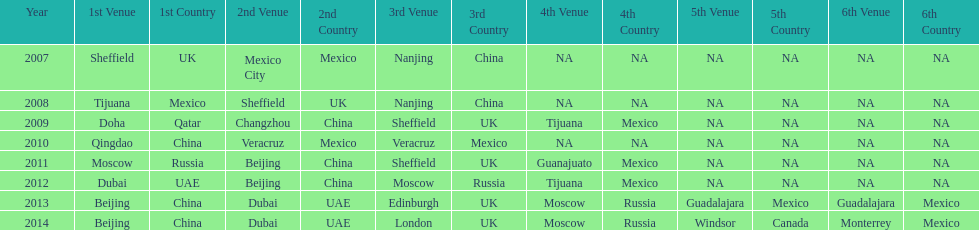In the list of venues, how many years was beijing ranked higher than moscow? 3. 